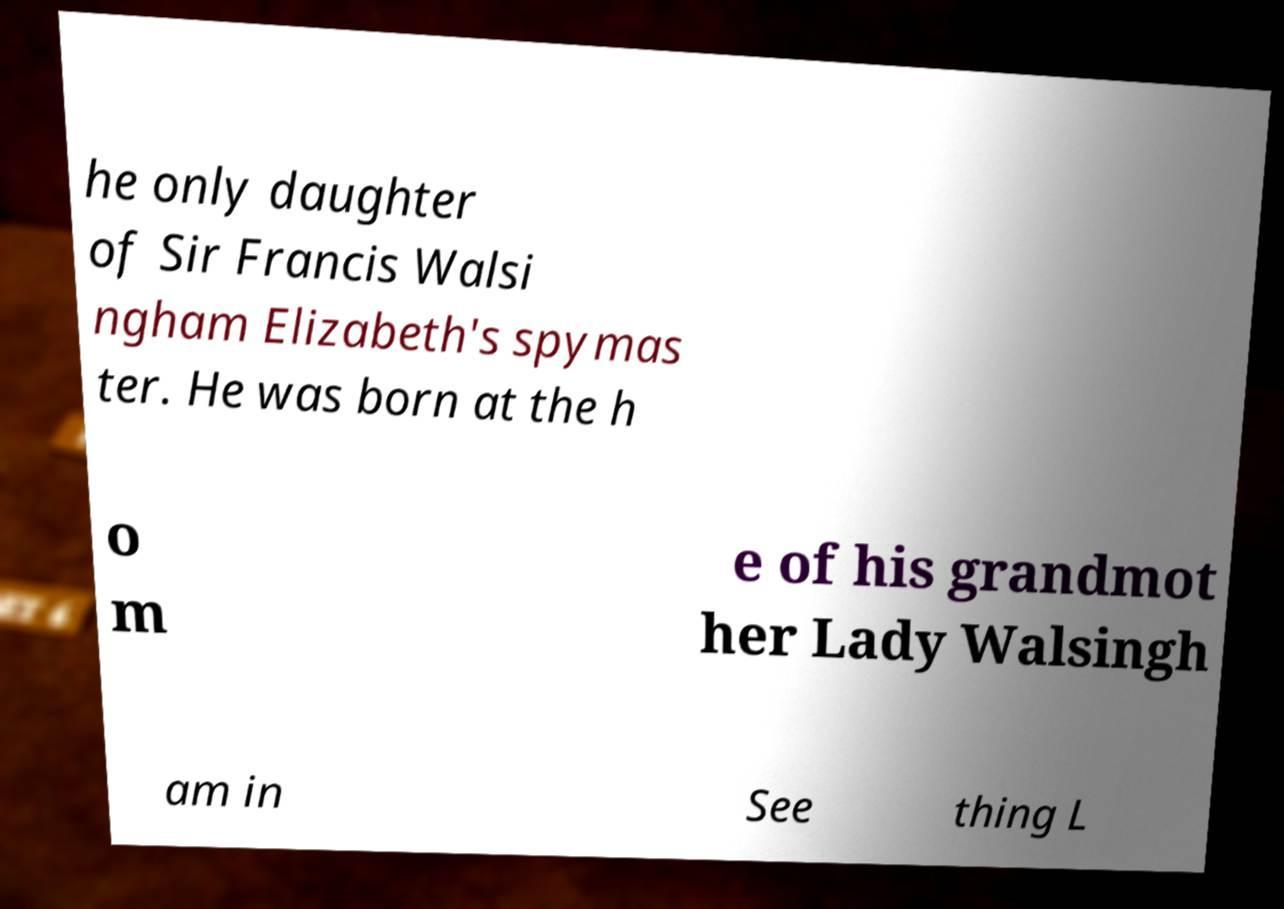Could you assist in decoding the text presented in this image and type it out clearly? he only daughter of Sir Francis Walsi ngham Elizabeth's spymas ter. He was born at the h o m e of his grandmot her Lady Walsingh am in See thing L 